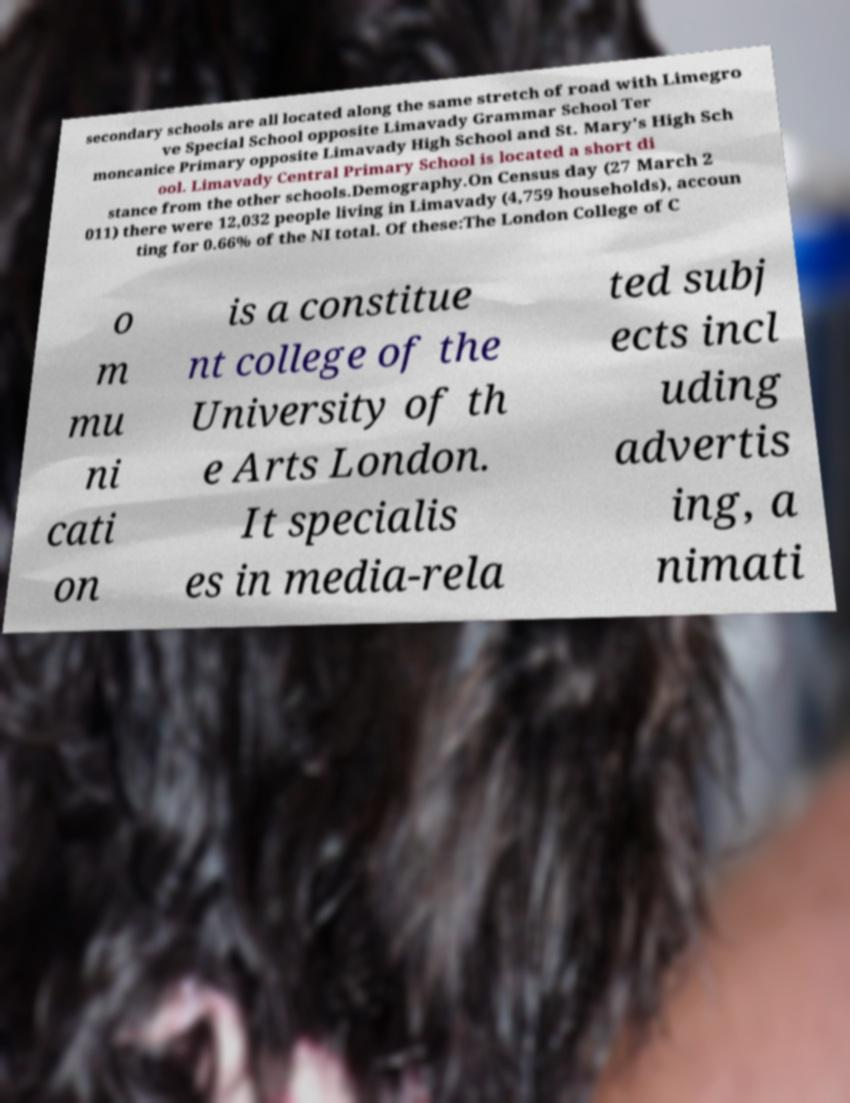I need the written content from this picture converted into text. Can you do that? secondary schools are all located along the same stretch of road with Limegro ve Special School opposite Limavady Grammar School Ter moncanice Primary opposite Limavady High School and St. Mary's High Sch ool. Limavady Central Primary School is located a short di stance from the other schools.Demography.On Census day (27 March 2 011) there were 12,032 people living in Limavady (4,759 households), accoun ting for 0.66% of the NI total. Of these:The London College of C o m mu ni cati on is a constitue nt college of the University of th e Arts London. It specialis es in media-rela ted subj ects incl uding advertis ing, a nimati 